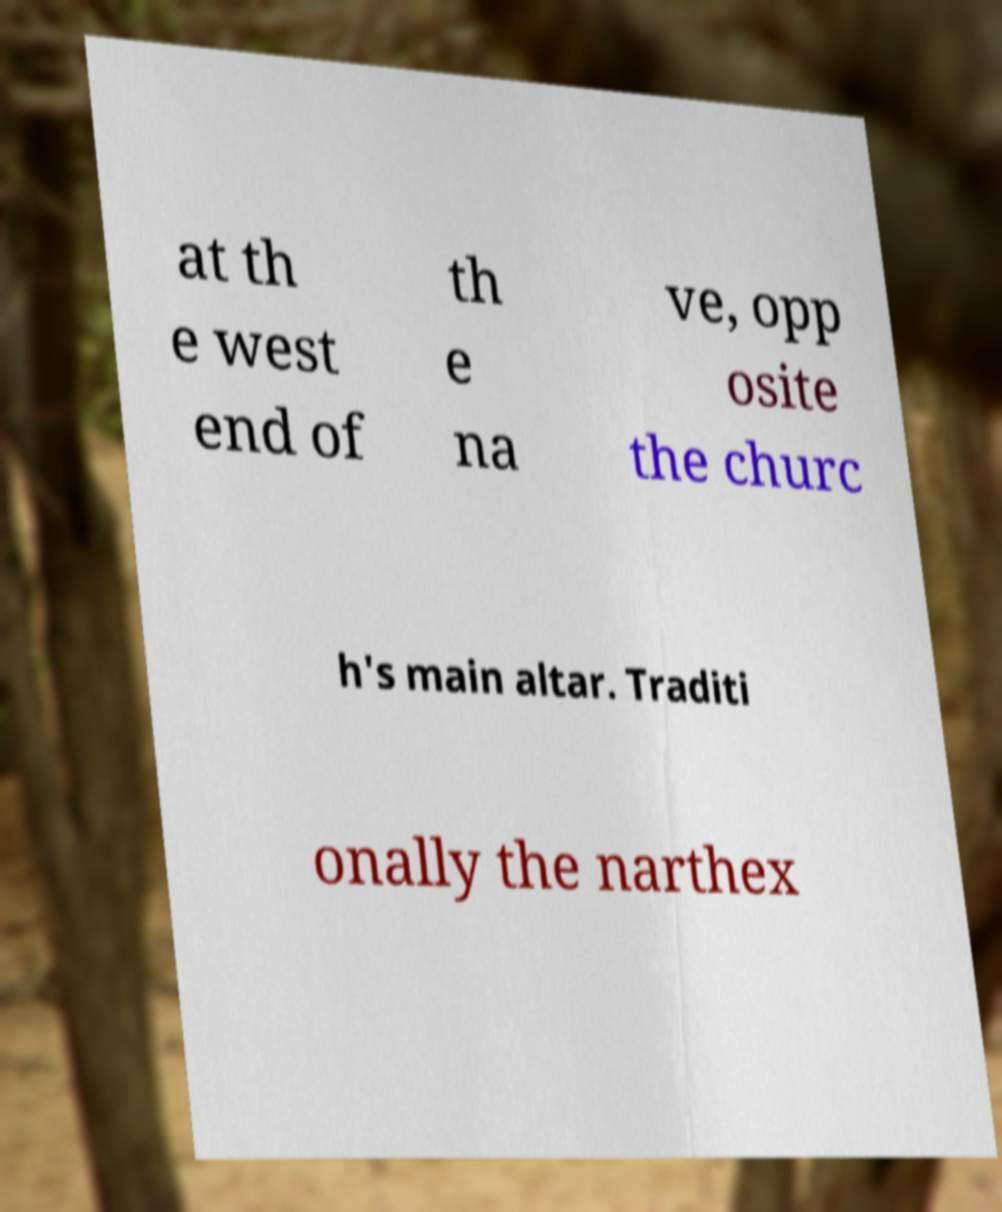For documentation purposes, I need the text within this image transcribed. Could you provide that? at th e west end of th e na ve, opp osite the churc h's main altar. Traditi onally the narthex 